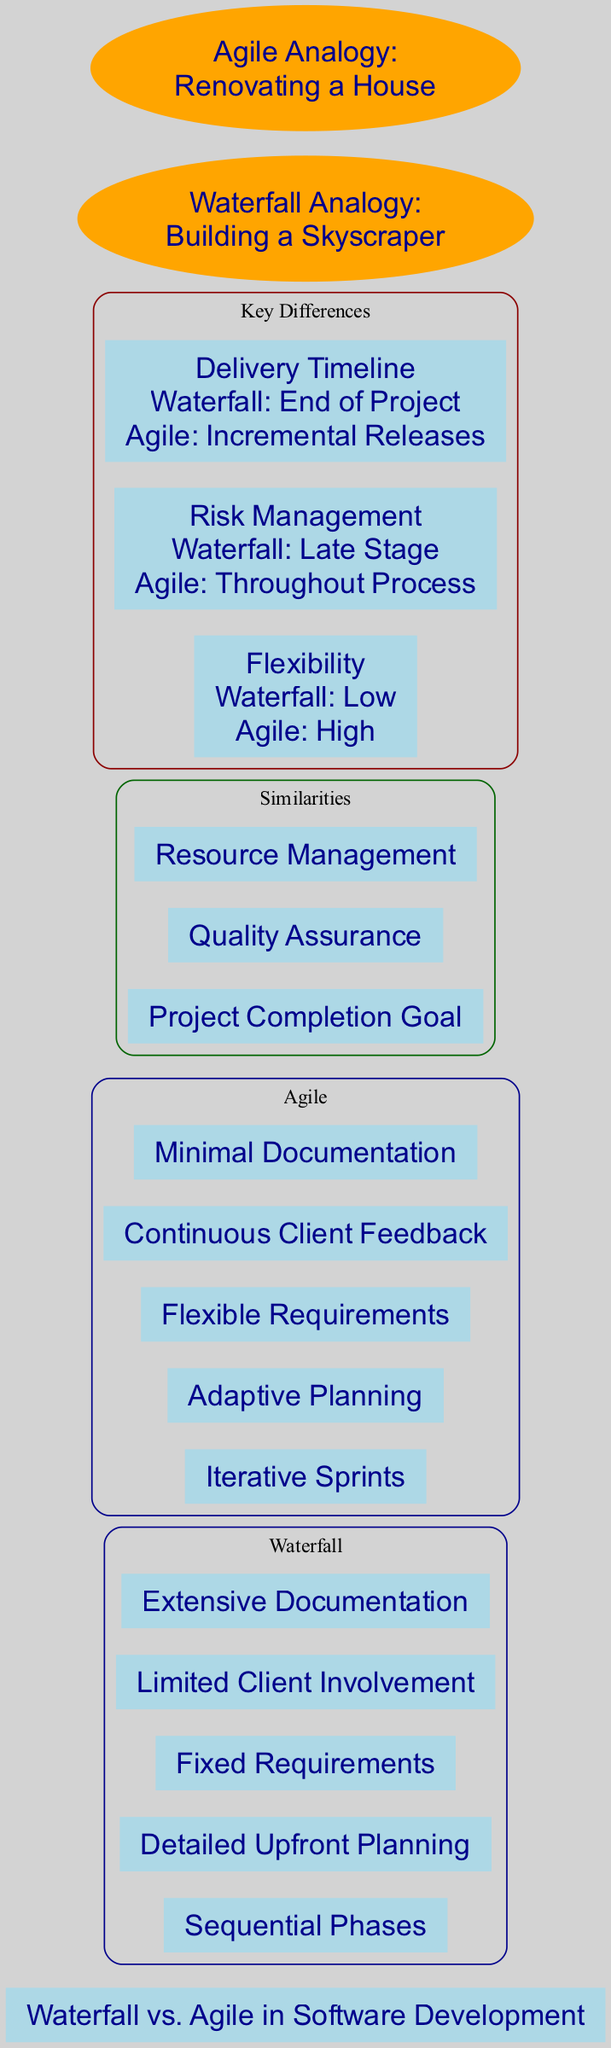What are the main phases in the Waterfall methodology? The Waterfall section lists five elements: "Sequential Phases", "Detailed Upfront Planning", "Fixed Requirements", "Limited Client Involvement", and "Extensive Documentation". Although only one answer is required, the user may refer to any of these elements as main phases.
Answer: Sequential Phases What is the delivery timeline for Agile? The diagram specifies that Agile has "Incremental Releases" for its delivery timeline, which contrasts with the Waterfall delivery method.
Answer: Incremental Releases How many key differences are there highlighted in the diagram? By counting the entries under the "Key Differences" section of the diagram, there are three distinct aspects listed: "Flexibility", "Risk Management", and "Delivery Timeline".
Answer: Three What type of planning does Agile use? The Agile section indicates "Adaptive Planning" as a characteristic of this methodology, suggesting a flexible approach.
Answer: Adaptive Planning In what stage does Waterfall manage risks? The diagram clearly states that Waterfall manages risks in the "Late Stage", indicating that issues are addressed later in the timeline.
Answer: Late Stage Which methodology has more extensive documentation? The Waterfall methodology is described as having "Extensive Documentation", while Agile is noted for having "Minimal Documentation", thus Waterfall is the methodology with more documentation.
Answer: Waterfall What is the analogy used for Waterfall in construction? The diagram defines the Waterfall analogy as "Building a Skyscraper", which implies a structured and sequential process akin to the Waterfall methodology.
Answer: Building a Skyscraper Which methodology incorporates continuous client feedback? The Agile methodology is noted for "Continuous Client Feedback", highlighting its interactive nature compared to Waterfall's limited involvement.
Answer: Agile What are the similarities shared by both methodologies? The diagram identifies three similarities: "Project Completion Goal", "Quality Assurance", and "Resource Management", thus these three shared characteristics represent the common elements.
Answer: Project Completion Goal, Quality Assurance, Resource Management 